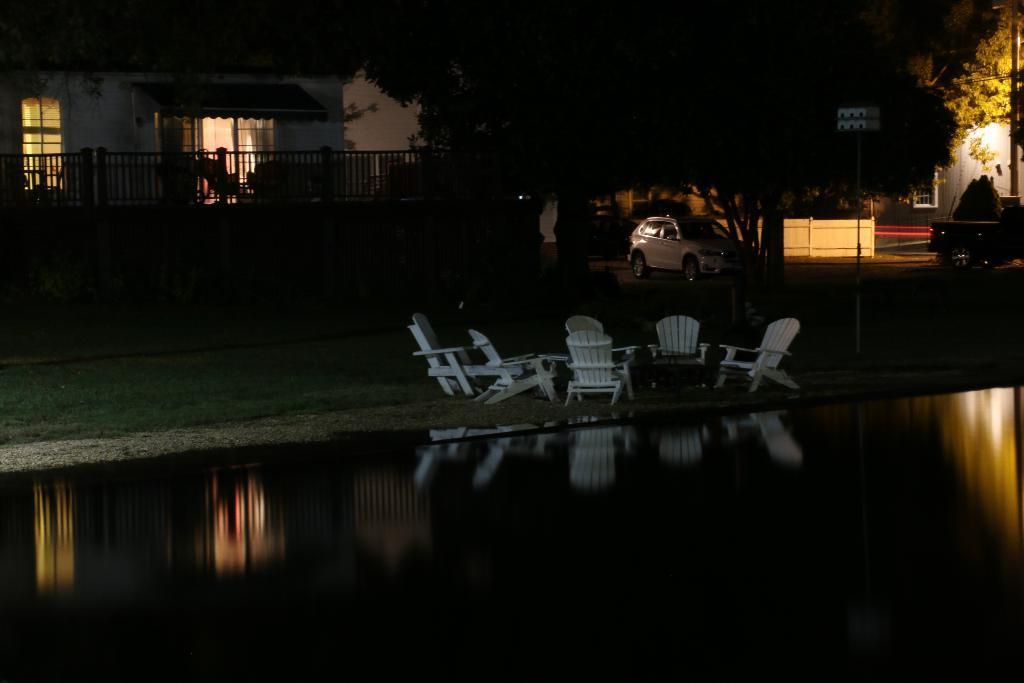How would you summarize this image in a sentence or two? In this image we can see chairs, water, grass, poles, car, fence, trees, wall, and a house. 